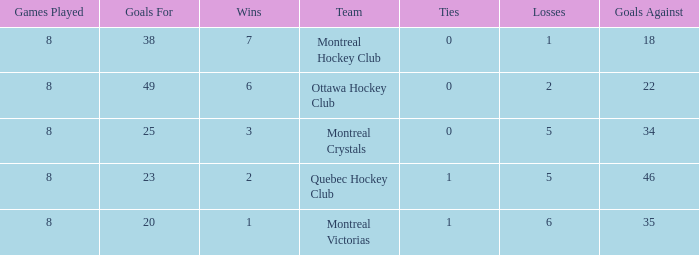What is the total number of goals for when the ties is more than 0, the goals against is more than 35 and the wins is less than 2? 0.0. 